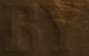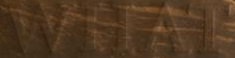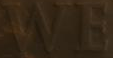Identify the words shown in these images in order, separated by a semicolon. BY; WHAT; WE 